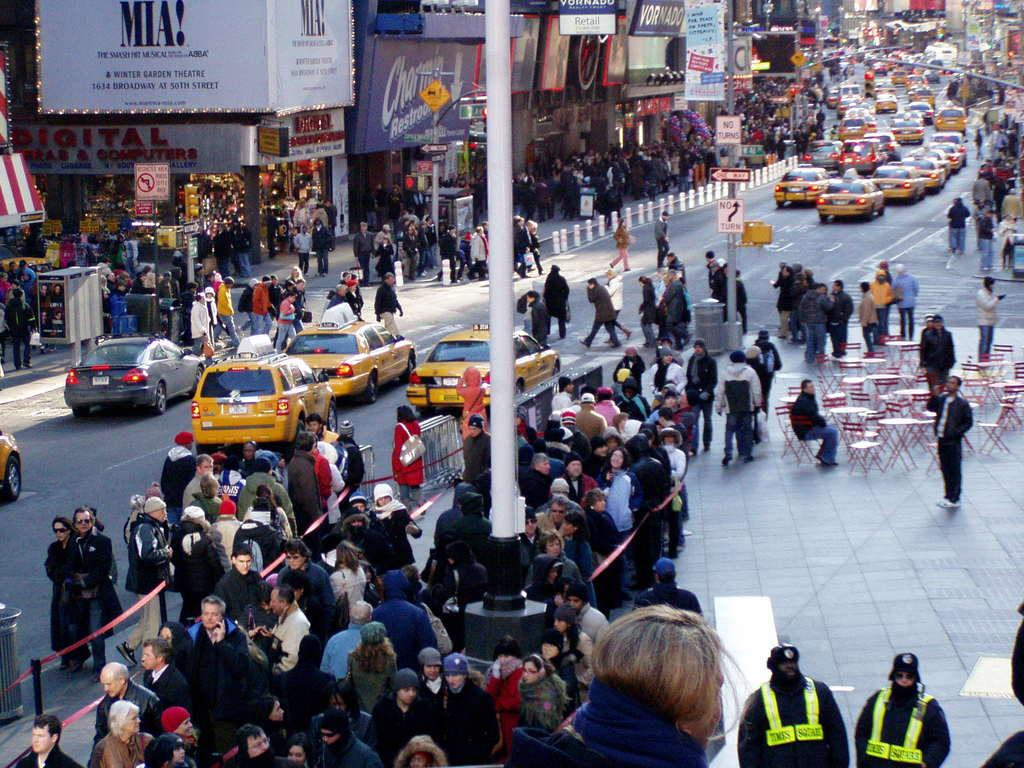<image>
Summarize the visual content of the image. A sign says, "Mia!" on the side of a busy street in the city. 